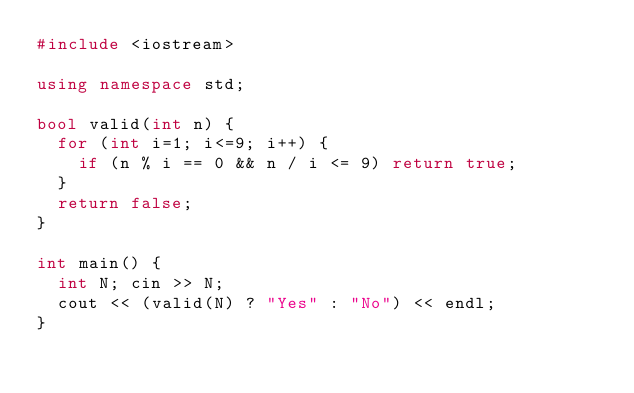Convert code to text. <code><loc_0><loc_0><loc_500><loc_500><_C++_>#include <iostream>

using namespace std;

bool valid(int n) {
  for (int i=1; i<=9; i++) {
    if (n % i == 0 && n / i <= 9) return true;
  }
  return false;
}

int main() {
  int N; cin >> N;
  cout << (valid(N) ? "Yes" : "No") << endl;
}</code> 